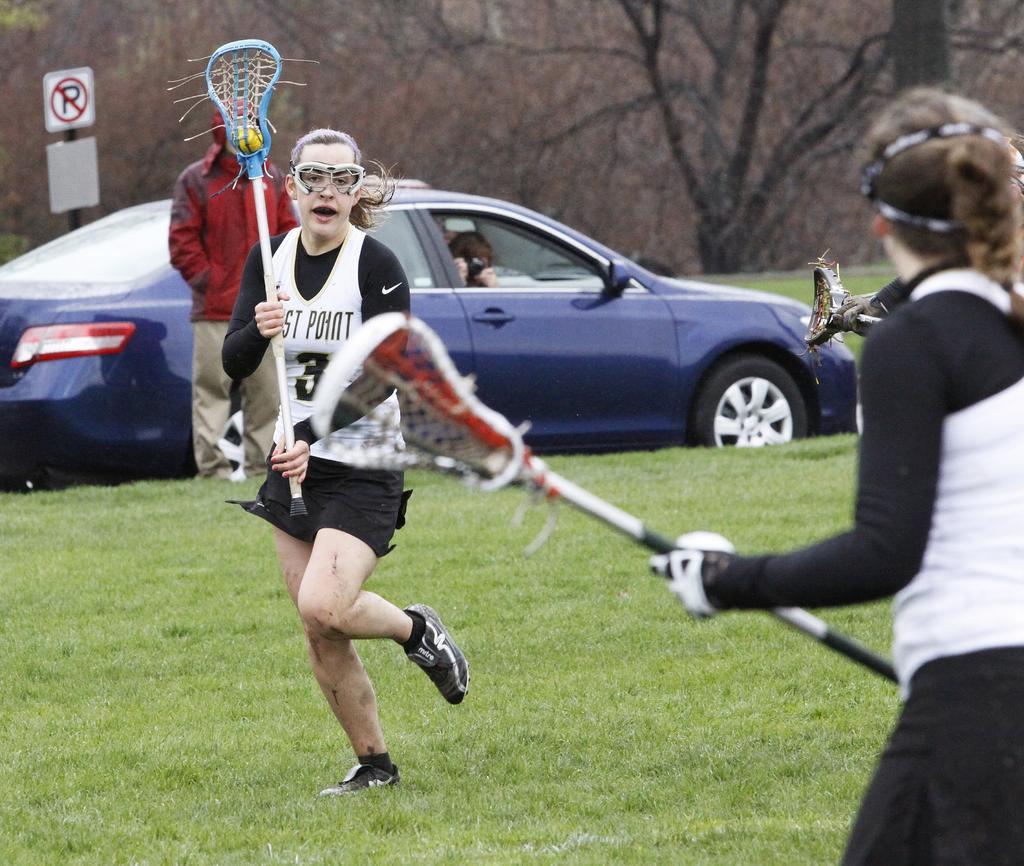Describe this image in one or two sentences. In the center of the image we can see three persons are standing and they are holding some objects. In the background, we can see trees, grass, one sign board, one car and one person standing. And we can see one person in the car and he is holding the camera. 